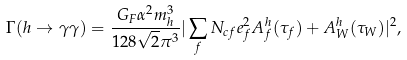Convert formula to latex. <formula><loc_0><loc_0><loc_500><loc_500>\Gamma ( h \rightarrow \gamma \gamma ) = \frac { G _ { F } \alpha ^ { 2 } m _ { h } ^ { 3 } } { 1 2 8 \sqrt { 2 } \pi ^ { 3 } } | \sum _ { f } N _ { c f } e _ { f } ^ { 2 } A _ { f } ^ { h } ( \tau _ { f } ) + A _ { W } ^ { h } ( \tau _ { W } ) | ^ { 2 } ,</formula> 